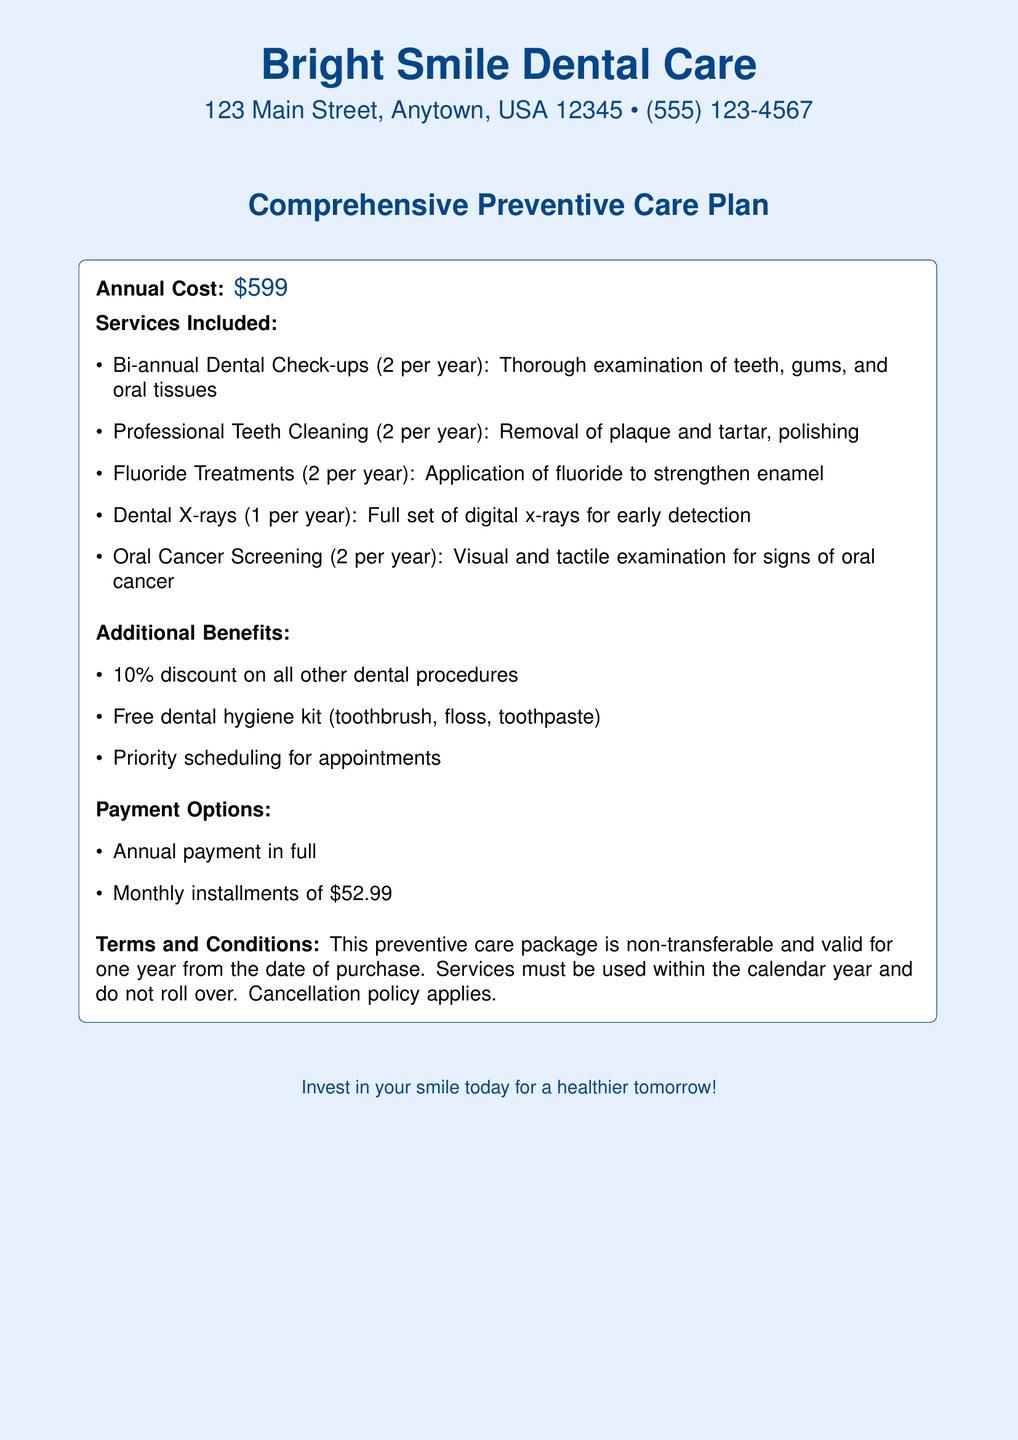what is the annual cost of the preventive care plan? The document explicitly states the annual cost of the preventive care plan, which is \$599.
Answer: \$599 how many dental check-ups are included per year? The document mentions that there are 2 bi-annual dental check-ups included per year.
Answer: 2 what additional benefit includes discounts? The document states that the plan offers a 10% discount on all other dental procedures as an additional benefit.
Answer: 10% discount how frequently are fluoride treatments provided? According to the list of services included, fluoride treatments are provided 2 times per year.
Answer: 2 per year what payment option is available for monthly installments? The document specifies that one of the payment options is monthly installments of \$52.99.
Answer: \$52.99 how many oral cancer screenings are included? The document indicates that there are 2 oral cancer screenings included in the plan per year.
Answer: 2 is the preventive care package transferable? The terms and conditions state that the preventive care package is non-transferable.
Answer: Non-transferable what service is performed only once a year? The document lists dental X-rays as the only service performed once per year.
Answer: Dental X-rays what is included in the free dental hygiene kit? The document mentions that the free dental hygiene kit includes a toothbrush, floss, and toothpaste.
Answer: Toothbrush, floss, toothpaste 